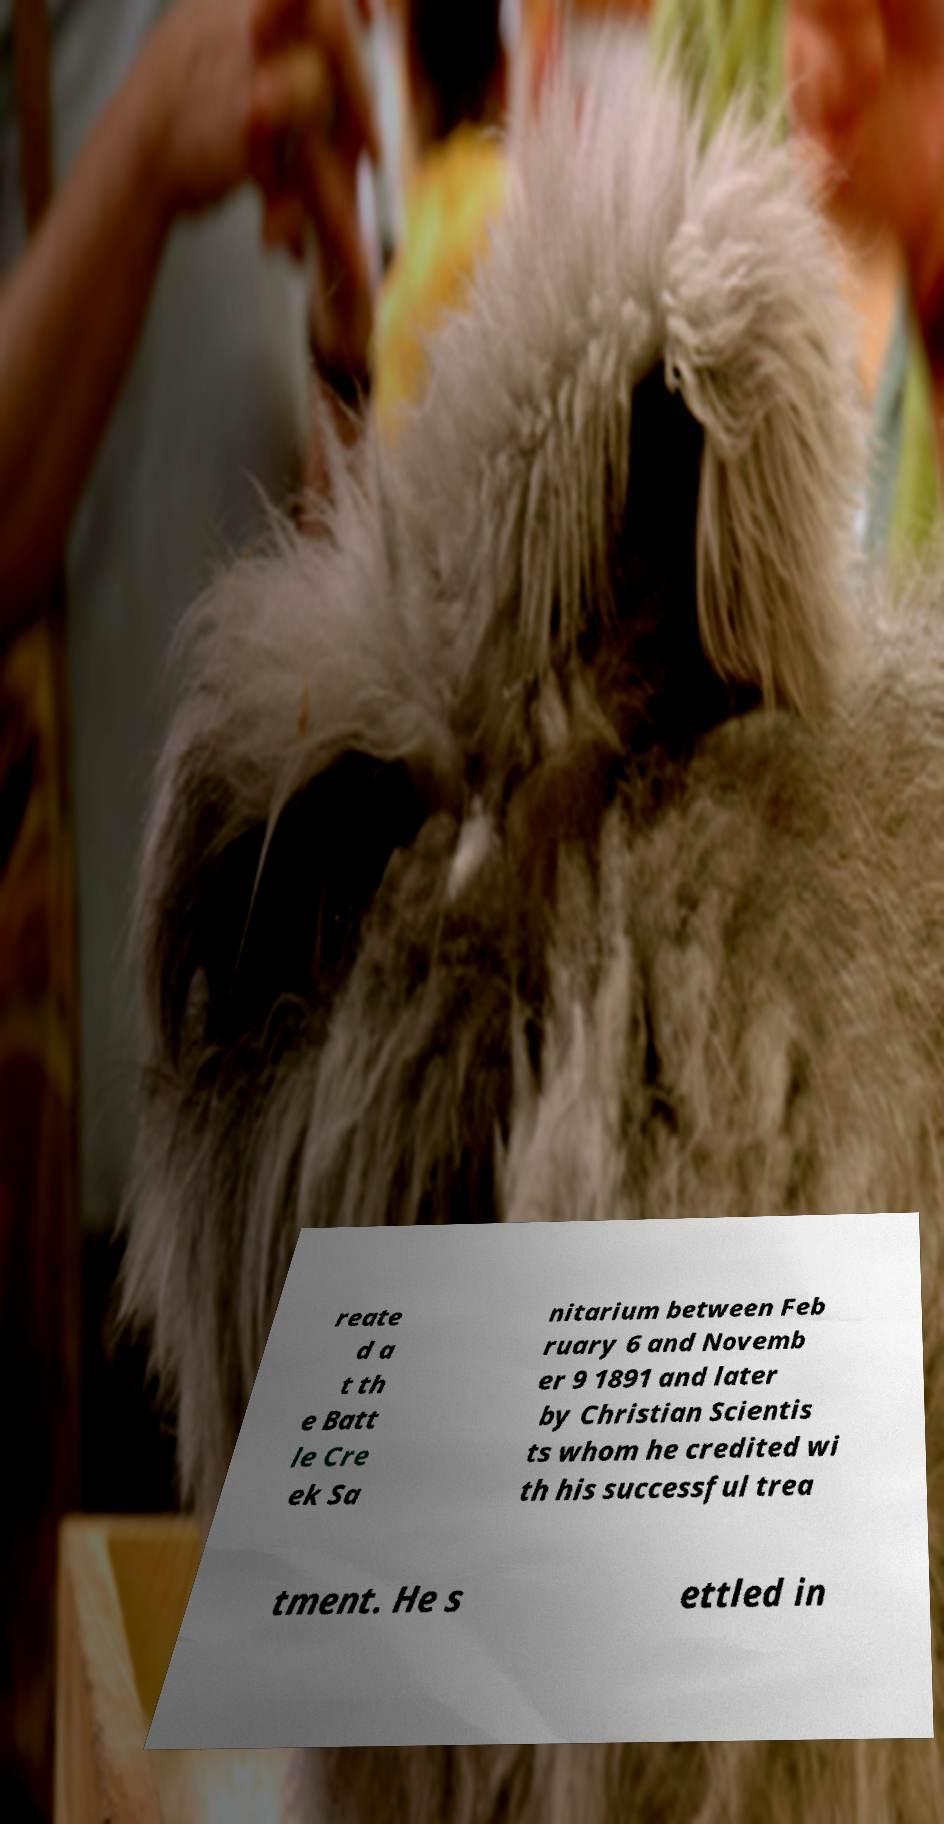I need the written content from this picture converted into text. Can you do that? reate d a t th e Batt le Cre ek Sa nitarium between Feb ruary 6 and Novemb er 9 1891 and later by Christian Scientis ts whom he credited wi th his successful trea tment. He s ettled in 